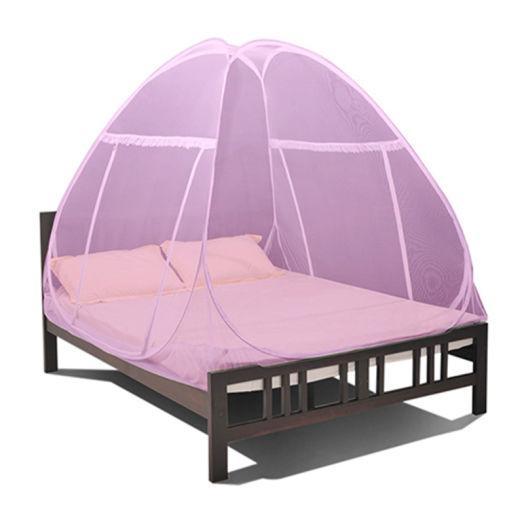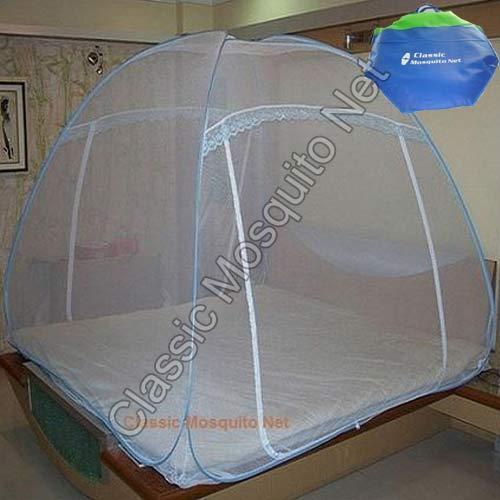The first image is the image on the left, the second image is the image on the right. Assess this claim about the two images: "Each image shows a bed with a dome-shaped canopy over its mattress like a tent, and at least one canopy has blue edges.". Correct or not? Answer yes or no. Yes. The first image is the image on the left, the second image is the image on the right. Examine the images to the left and right. Is the description "One bed netting is pink." accurate? Answer yes or no. Yes. 